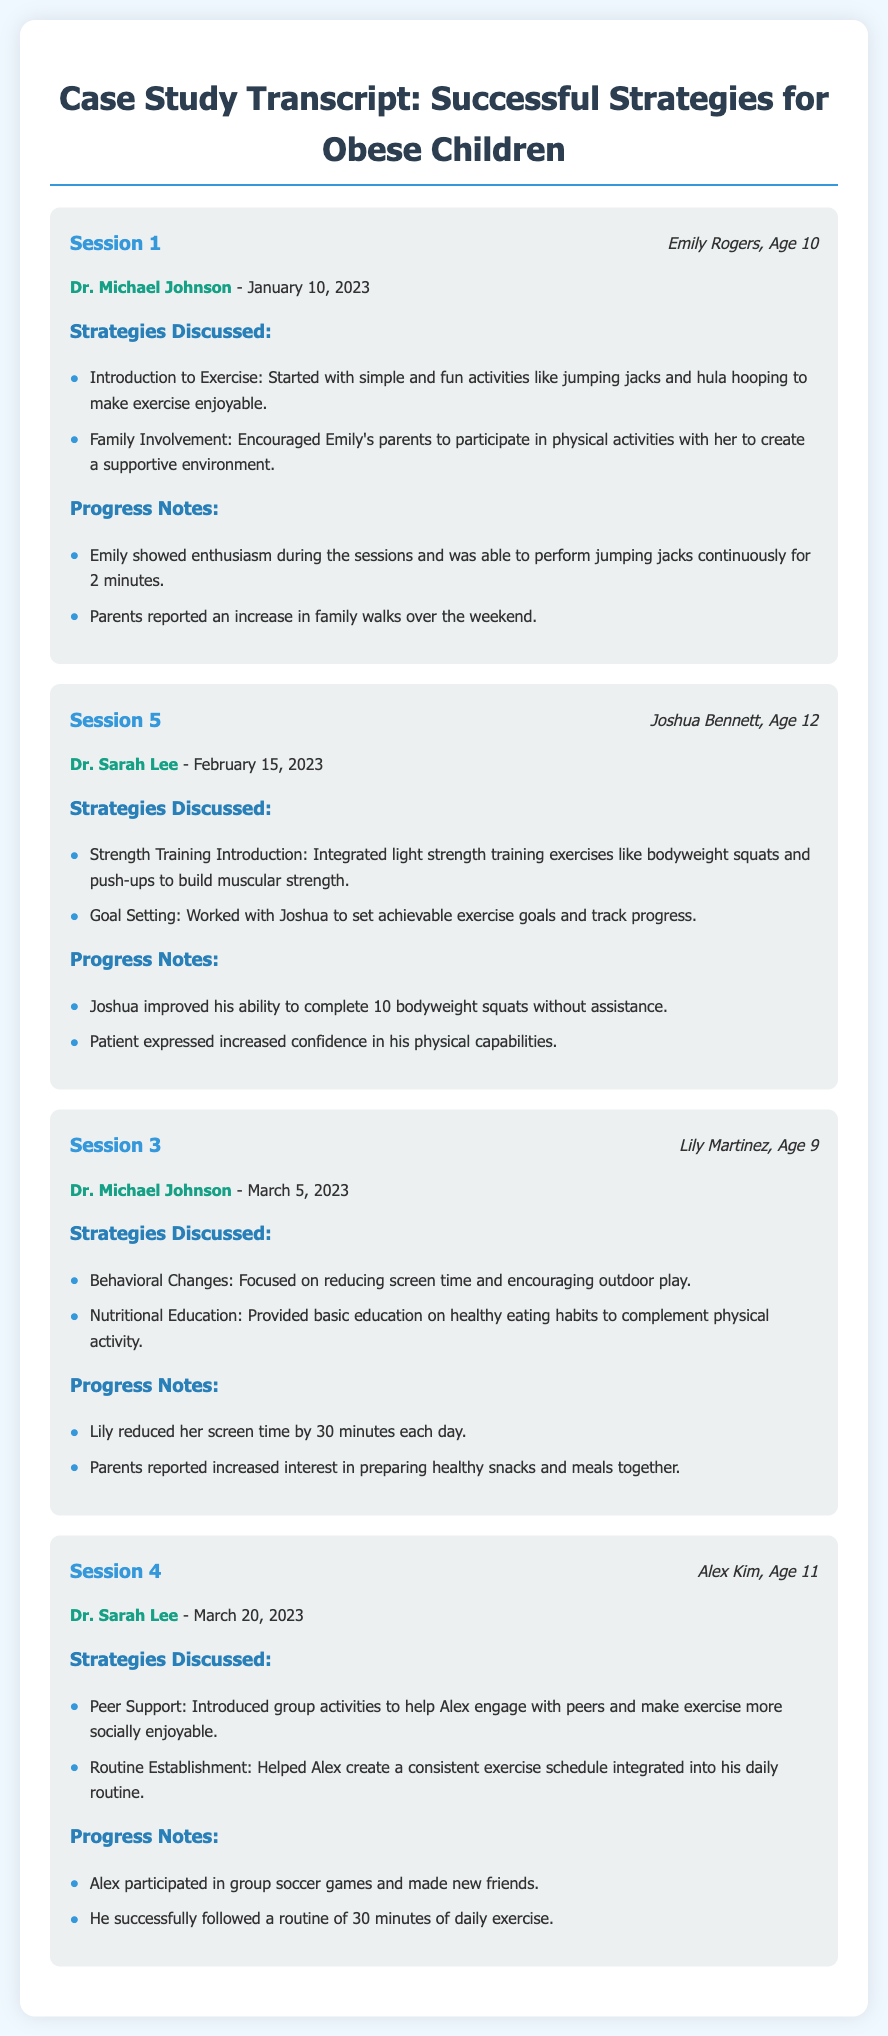What is the name of the therapist in Session 1? The therapist in Session 1 is Dr. Michael Johnson, as mentioned in the document.
Answer: Dr. Michael Johnson What age is Joshua Bennett? Joshua Bennett is 12 years old, which is indicated in his patient information in the document.
Answer: 12 What exercise did Emily perform for 2 minutes? Emily performed jumping jacks continuously for 2 minutes, detailed in the progress notes of Session 1.
Answer: jumping jacks How many bodyweight squats could Joshua complete without assistance? Joshua improved his ability to complete 10 bodyweight squats without assistance, described in his progress notes.
Answer: 10 What change did Lily make to her screen time? Lily reduced her screen time by 30 minutes each day, noted in the progress section of Session 3.
Answer: 30 minutes What activity did Alex participate in to engage with peers? Alex participated in group soccer games, as stated in the progress notes for Session 4.
Answer: group soccer games What type of training was introduced to Joshua in Session 5? Light strength training exercises like bodyweight squats and push-ups were introduced in Session 5.
Answer: light strength training exercises Which strategy focused on family involvement? The strategy encouraging Emily’s parents to participate in physical activities with her focused on family involvement.
Answer: family involvement What date was Session 3 held? Session 3 was held on March 5, 2023, as noted in the document.
Answer: March 5, 2023 